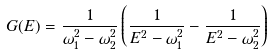<formula> <loc_0><loc_0><loc_500><loc_500>G ( E ) = \frac { 1 } { \omega _ { 1 } ^ { 2 } - \omega _ { 2 } ^ { 2 } } \left ( \frac { 1 } { E ^ { 2 } - \omega _ { 1 } ^ { 2 } } - \frac { 1 } { E ^ { 2 } - \omega _ { 2 } ^ { 2 } } \right )</formula> 